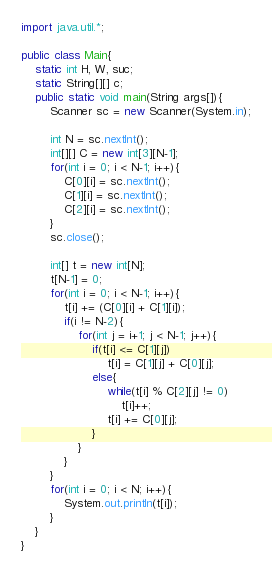Convert code to text. <code><loc_0><loc_0><loc_500><loc_500><_Java_>import java.util.*;
 
public class Main{
    static int H, W, suc;
    static String[][] c;
    public static void main(String args[]){
        Scanner sc = new Scanner(System.in);
        
        int N = sc.nextInt();
        int[][] C = new int[3][N-1];
        for(int i = 0; i < N-1; i++){
            C[0][i] = sc.nextInt();
            C[1][i] = sc.nextInt();
            C[2][i] = sc.nextInt();
        }
        sc.close();

        int[] t = new int[N];
        t[N-1] = 0;
        for(int i = 0; i < N-1; i++){
            t[i] += (C[0][i] + C[1][i]);
            if(i != N-2){
                for(int j = i+1; j < N-1; j++){
                    if(t[i] <= C[1][j])
                        t[i] = C[1][j] + C[0][j];
                    else{
                        while(t[i] % C[2][j] != 0)
                            t[i]++;
                        t[i] += C[0][j];
                    }
                }
            }
        }
        for(int i = 0; i < N; i++){
            System.out.println(t[i]);
        }
    }
}</code> 